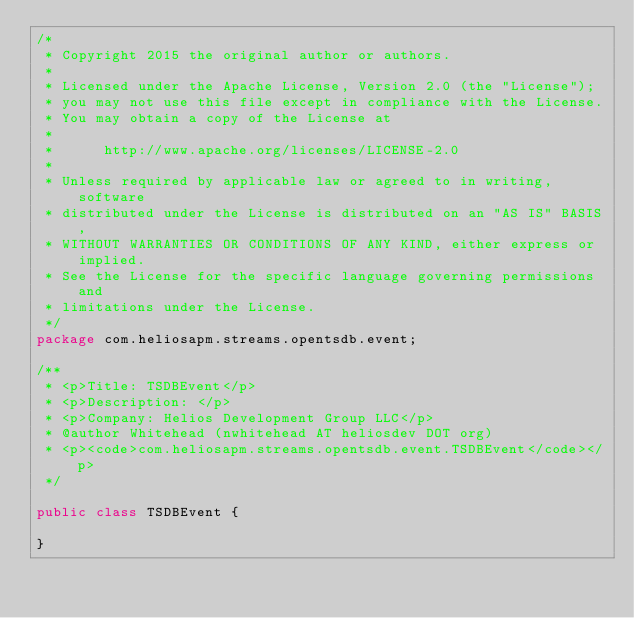Convert code to text. <code><loc_0><loc_0><loc_500><loc_500><_Java_>/*
 * Copyright 2015 the original author or authors.
 *
 * Licensed under the Apache License, Version 2.0 (the "License");
 * you may not use this file except in compliance with the License.
 * You may obtain a copy of the License at
 *
 *      http://www.apache.org/licenses/LICENSE-2.0
 *
 * Unless required by applicable law or agreed to in writing, software
 * distributed under the License is distributed on an "AS IS" BASIS,
 * WITHOUT WARRANTIES OR CONDITIONS OF ANY KIND, either express or implied.
 * See the License for the specific language governing permissions and
 * limitations under the License.
 */
package com.heliosapm.streams.opentsdb.event;

/**
 * <p>Title: TSDBEvent</p>
 * <p>Description: </p> 
 * <p>Company: Helios Development Group LLC</p>
 * @author Whitehead (nwhitehead AT heliosdev DOT org)
 * <p><code>com.heliosapm.streams.opentsdb.event.TSDBEvent</code></p>
 */

public class TSDBEvent {

}
</code> 